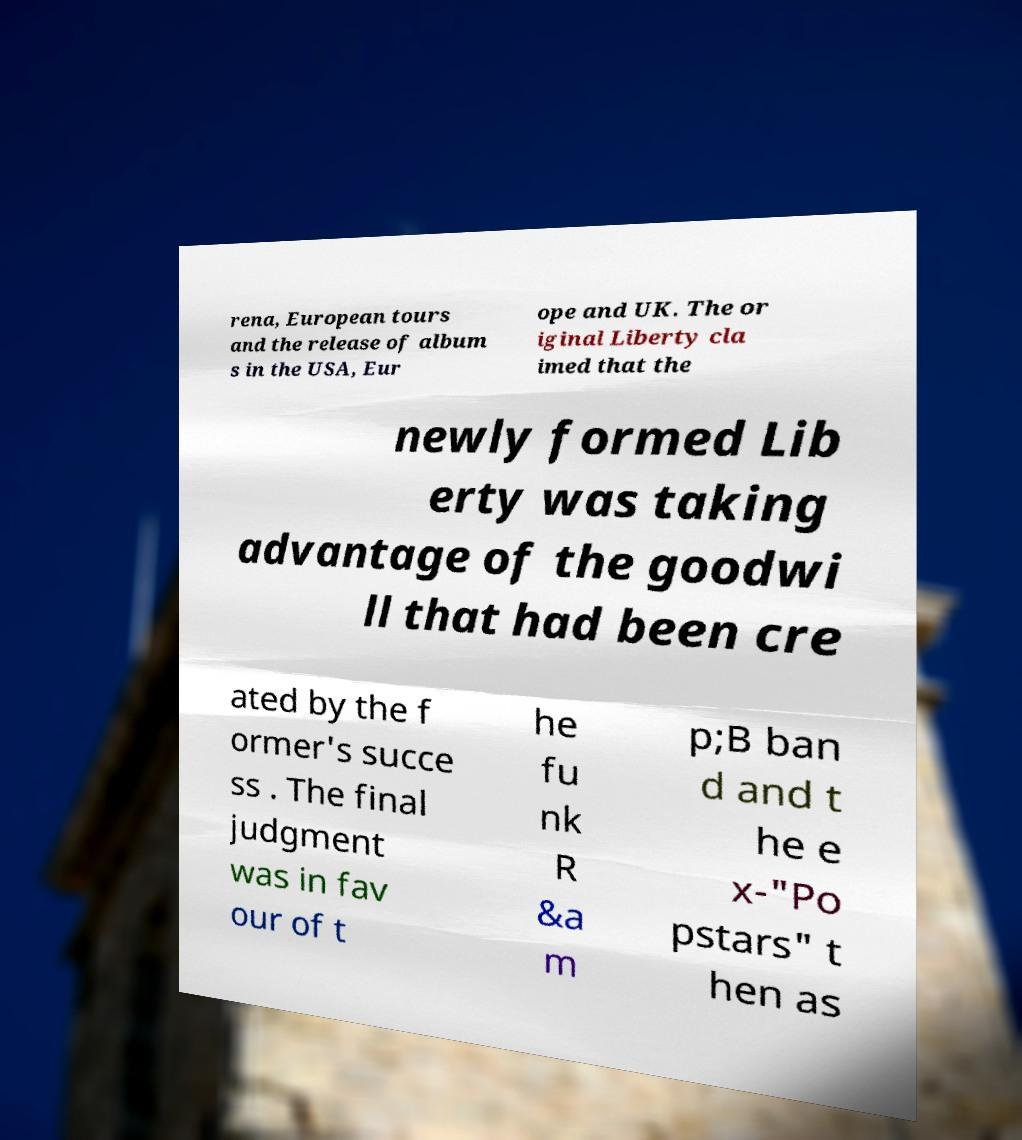Could you assist in decoding the text presented in this image and type it out clearly? rena, European tours and the release of album s in the USA, Eur ope and UK. The or iginal Liberty cla imed that the newly formed Lib erty was taking advantage of the goodwi ll that had been cre ated by the f ormer's succe ss . The final judgment was in fav our of t he fu nk R &a m p;B ban d and t he e x-"Po pstars" t hen as 